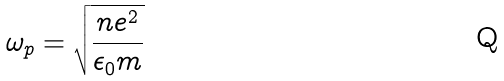<formula> <loc_0><loc_0><loc_500><loc_500>\omega _ { p } = \sqrt { \frac { n e ^ { 2 } } { \epsilon _ { 0 } m } }</formula> 